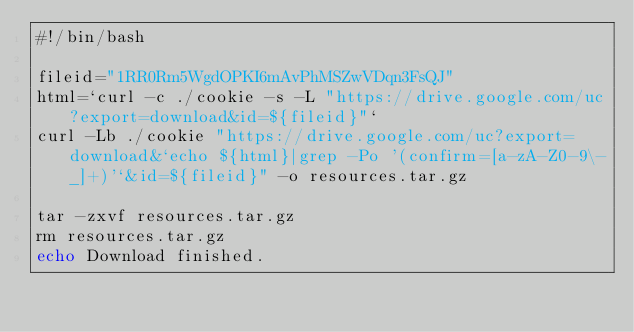Convert code to text. <code><loc_0><loc_0><loc_500><loc_500><_Bash_>#!/bin/bash

fileid="1RR0Rm5WgdOPKI6mAvPhMSZwVDqn3FsQJ"
html=`curl -c ./cookie -s -L "https://drive.google.com/uc?export=download&id=${fileid}"`
curl -Lb ./cookie "https://drive.google.com/uc?export=download&`echo ${html}|grep -Po '(confirm=[a-zA-Z0-9\-_]+)'`&id=${fileid}" -o resources.tar.gz

tar -zxvf resources.tar.gz
rm resources.tar.gz
echo Download finished.
</code> 